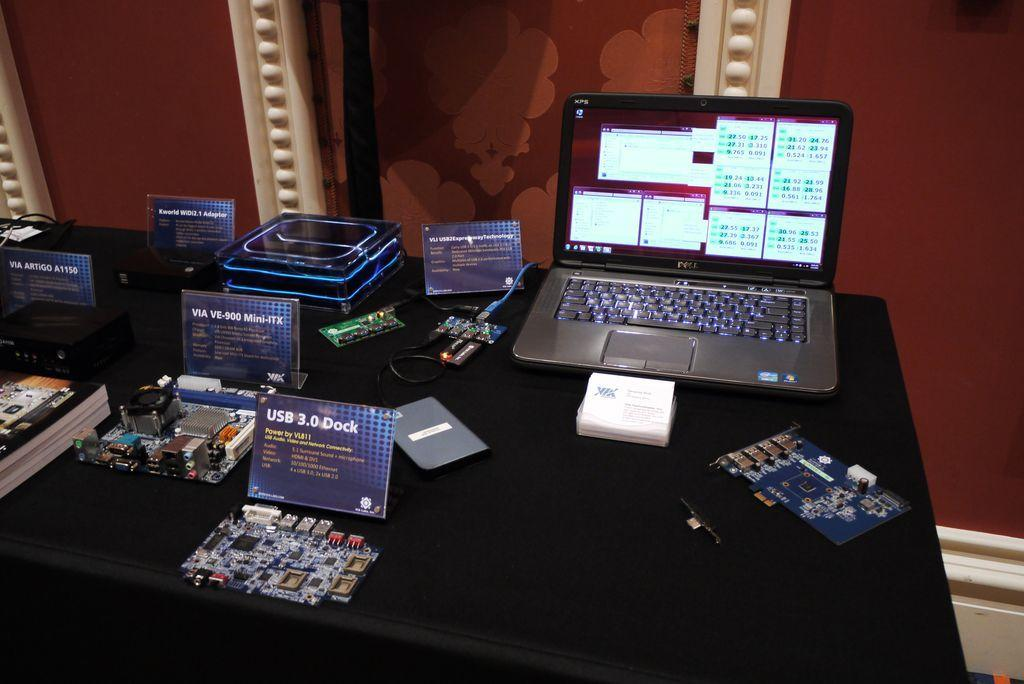Provide a one-sentence caption for the provided image. A laptop computer made by Dell open on a table. 